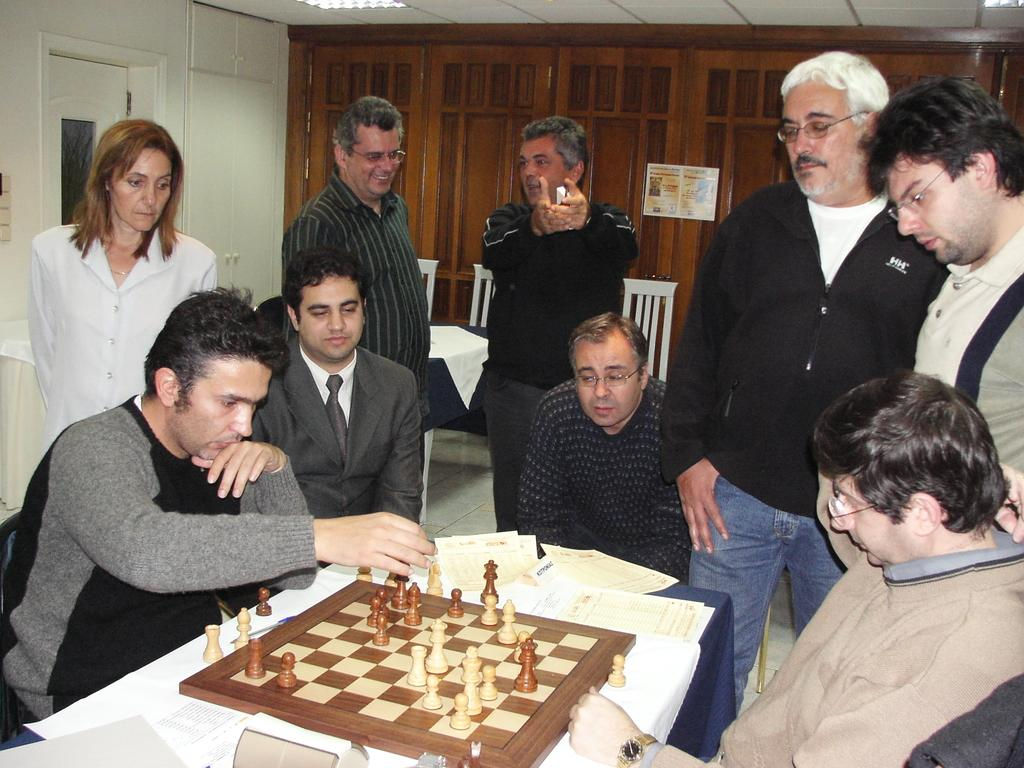How many people are in the image? There are four persons in the image. What are the positions of the persons in the image? Some of the persons are sitting on chairs, while others are standing. What is on the table in the image? There is a chess board and papers on the table. What can be seen in the background of the image? There is a wall visible in the background. What type of rabbit can be seen playing with a snake in the image? There is no rabbit or snake present in the image. What class are the persons attending in the image? There is no indication of a class or educational setting in the image. 